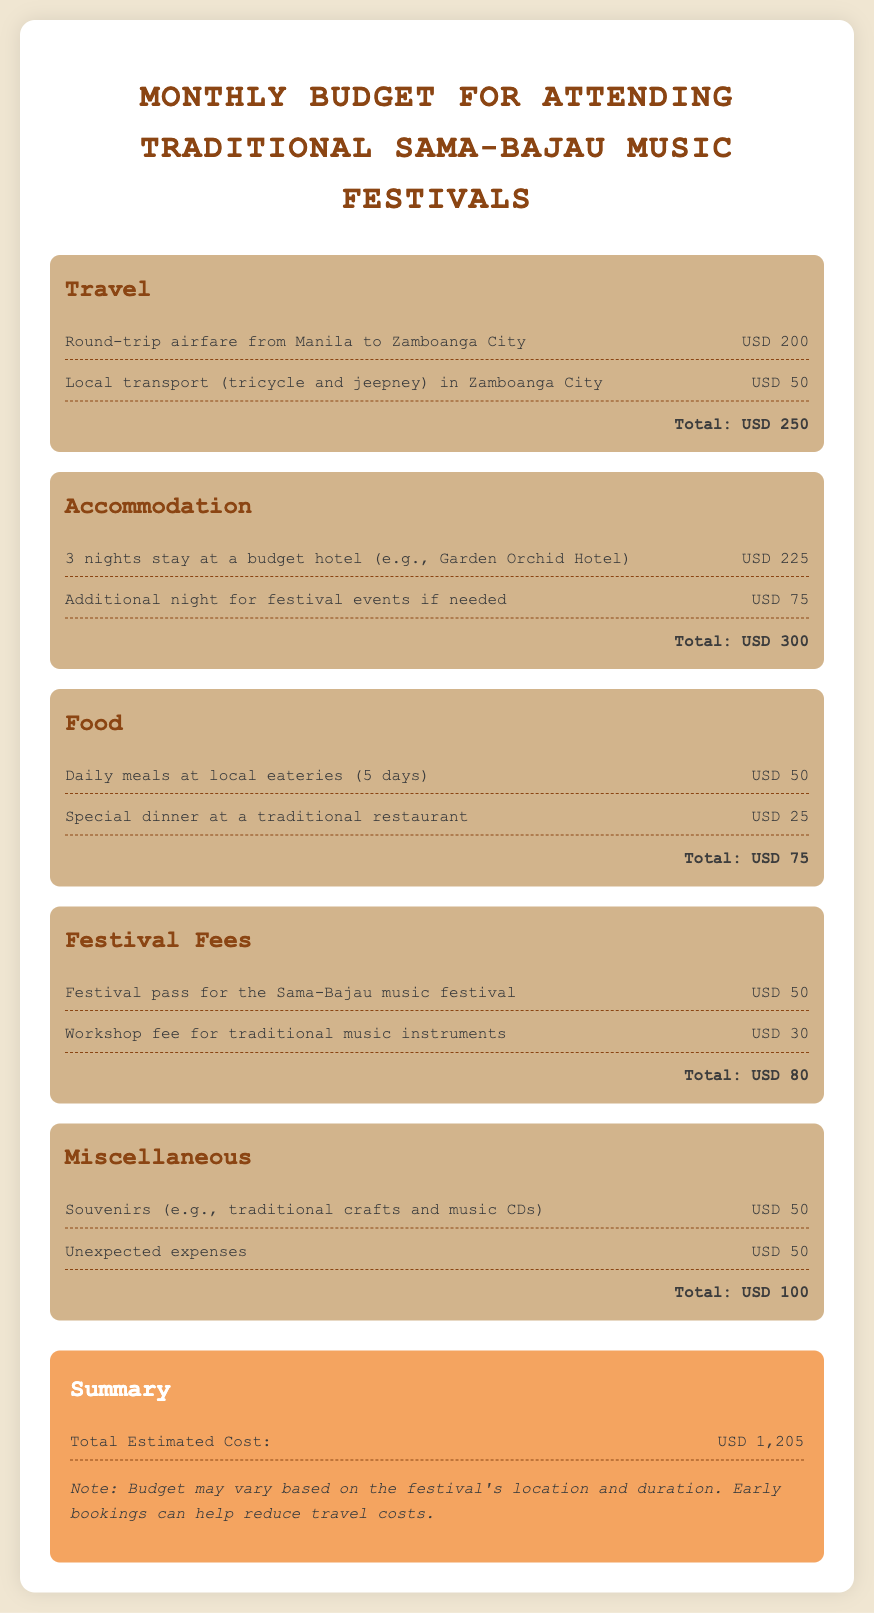What is the total budget for attending traditional Sama-Bajau music festivals? The total budget is listed as the total estimated cost at the end of the document, which sums all expenses.
Answer: USD 1,205 How much is the round-trip airfare from Manila to Zamboanga City? The document specifically lists the cost of the round-trip airfare in the travel category, indicating how much it costs to travel from Manila to Zamboanga City.
Answer: USD 200 What is the accommodation cost for three nights at a budget hotel? The accommodation section details the cost for a three-night stay, making it clear how much this specific expense would be.
Answer: USD 225 How much is allocated for daily meals at local eateries? The food section specifies the total cost for daily meals for the designated time period, providing clarity on food expenses.
Answer: USD 50 What is the cost of the festival pass for the Sama-Bajau music festival? The festival fees section includes this expense, clearly indicating what participants need to pay to attend the festival.
Answer: USD 50 What is the total estimated cost for food expenses? The food category sums up all food-related expenses, outlining how much is expected to be spent on food during the festival.
Answer: USD 75 How much is budgeted for unexpected expenses? The miscellaneous section reveals how much is reserved for unexpected expenses, which is an important part of budgeting.
Answer: USD 50 What are the total transportation costs in Zamboanga City? The travel section clearly states the various local transport costs, allowing for an understanding of transportation expenses.
Answer: USD 50 What is the combined cost of souvenirs and unexpected expenses? The document clearly lists the individual prices, allowing for straightforward addition of these amounts to answer the question.
Answer: USD 100 